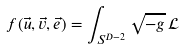Convert formula to latex. <formula><loc_0><loc_0><loc_500><loc_500>f ( \vec { u } , \vec { v } , \vec { e } ) = \int _ { S ^ { D - 2 } } \sqrt { - g } \, \mathcal { L }</formula> 